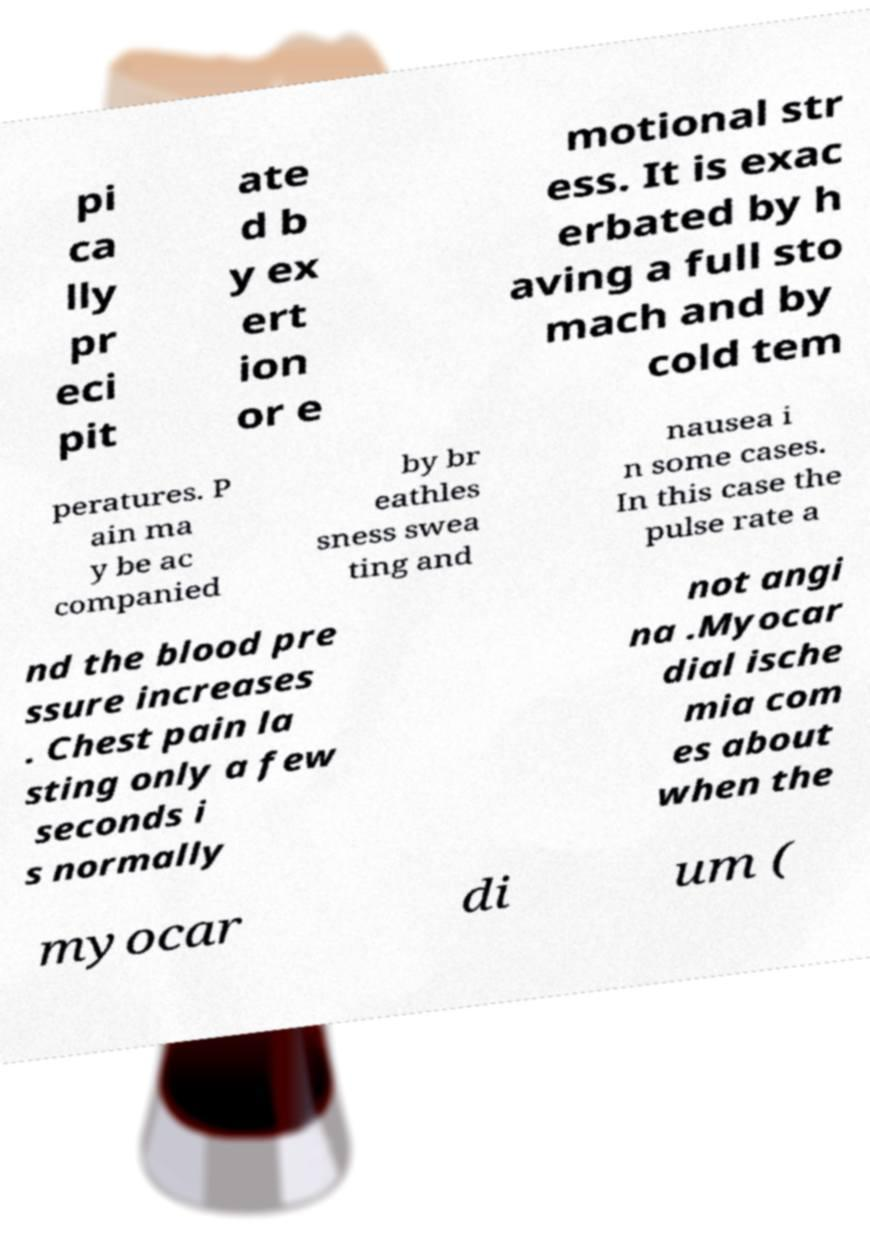What messages or text are displayed in this image? I need them in a readable, typed format. pi ca lly pr eci pit ate d b y ex ert ion or e motional str ess. It is exac erbated by h aving a full sto mach and by cold tem peratures. P ain ma y be ac companied by br eathles sness swea ting and nausea i n some cases. In this case the pulse rate a nd the blood pre ssure increases . Chest pain la sting only a few seconds i s normally not angi na .Myocar dial ische mia com es about when the myocar di um ( 